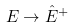Convert formula to latex. <formula><loc_0><loc_0><loc_500><loc_500>E \rightarrow \hat { E } ^ { + }</formula> 